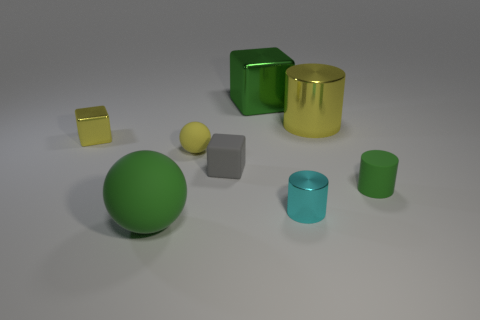Subtract all tiny cubes. How many cubes are left? 1 Add 1 tiny purple metal cylinders. How many objects exist? 9 Subtract all balls. How many objects are left? 6 Add 7 yellow spheres. How many yellow spheres are left? 8 Add 3 cyan metallic spheres. How many cyan metallic spheres exist? 3 Subtract 0 purple cylinders. How many objects are left? 8 Subtract all metallic cylinders. Subtract all green cylinders. How many objects are left? 5 